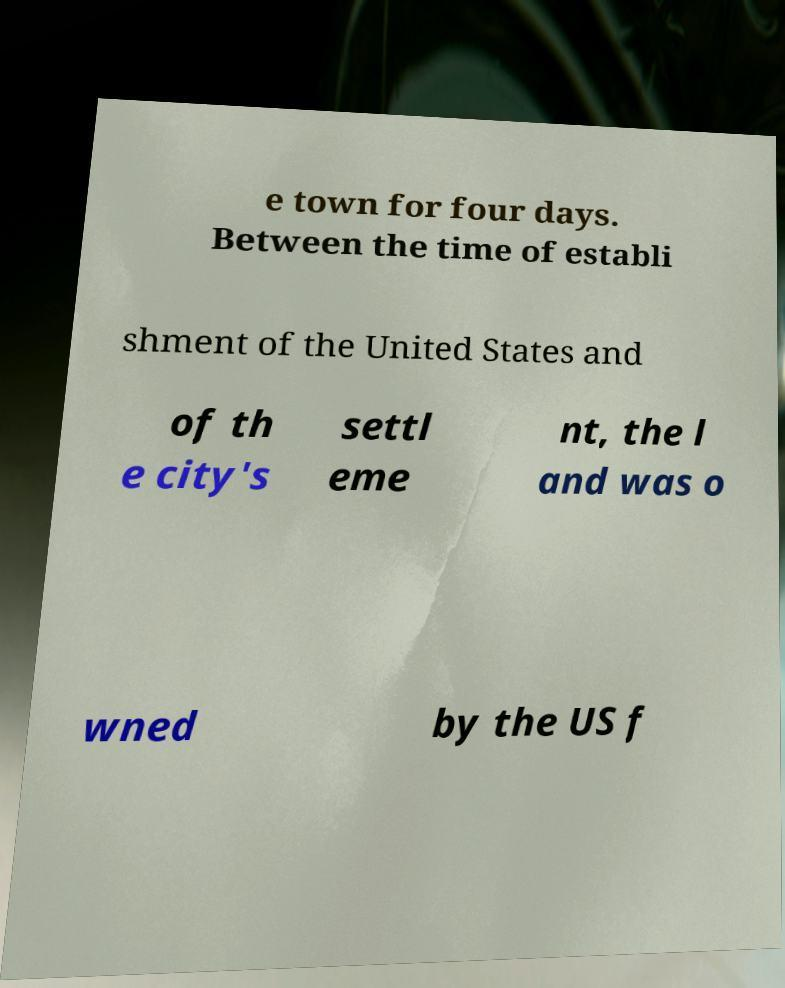Can you read and provide the text displayed in the image?This photo seems to have some interesting text. Can you extract and type it out for me? e town for four days. Between the time of establi shment of the United States and of th e city's settl eme nt, the l and was o wned by the US f 